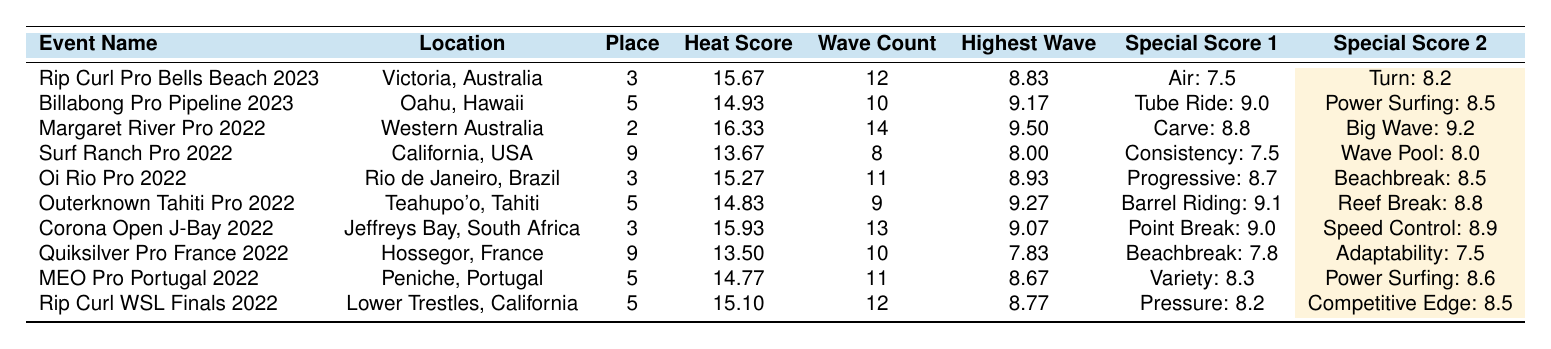What was Ethan Ewing's highest wave score at the Rip Curl Pro Bells Beach 2023? The table shows that at the Rip Curl Pro Bells Beach 2023, Ethan's highest wave score was 8.83.
Answer: 8.83 Which event did Ethan Ewing achieve the highest heat score? By looking at the heat scores in the table, the highest score is 16.33 at the Margaret River Pro 2022.
Answer: 16.33 How many total waves did Ethan Ewing ride in the Billabong Pro Pipeline 2023? The table indicates that in the Billabong Pro Pipeline 2023, he rode 10 waves.
Answer: 10 What place did Ethan Ewing finish in the Surf Ranch Pro 2022? According to the table, Ethan placed 9th in the Surf Ranch Pro 2022.
Answer: 9th What is the average highest wave score across all events listed? To find the average highest wave score, we sum the highest scores (8.83, 9.17, 9.50, 8.00, 8.93, 9.27, 9.07, 7.83, 8.67, 8.77) which equals 88.27. There are 10 events, so the average is 88.27/10 = 8.827.
Answer: 8.827 Did Ethan Ewing achieve a score of above 9.0 in any special score at the Outerknown Tahiti Pro 2022? In the table, it shows that at the Outerknown Tahiti Pro 2022, Ethan's barrel riding score was 9.1, which is above 9.0.
Answer: Yes What is the difference between Ethan Ewing's highest wave score at the Margaret River Pro 2022 and that at the Surf Ranch Pro 2022? The highest wave score at the Margaret River Pro 2022 is 9.50, and at the Surf Ranch Pro 2022, it's 8.00. The difference is 9.50 - 8.00 = 1.50.
Answer: 1.50 At which event did Ethan Ewing have the highest wave count? The highest wave count listed in the table is 14 waves at the Margaret River Pro 2022.
Answer: 14 Which event had the best average placement for Ethan Ewing based on the table? We look at the placement data: 3, 5, 2, 9, 3, 5, 3, 9, 5, 5. By calculating the average placement, we find that the lowest score is 2 (Margaret River Pro 2022), showing it was his top performance.
Answer: Margaret River Pro 2022 How many events did Ethan Ewing finish in the top 3? From the table, Ethan finished in the top 3 (1st, 2nd, or 3rd place) at five events: Rip Curl Pro Bells Beach, Margaret River Pro, Oi Rio Pro, Corona Open J-Bay, and Surf Ranch Pro.
Answer: 5 